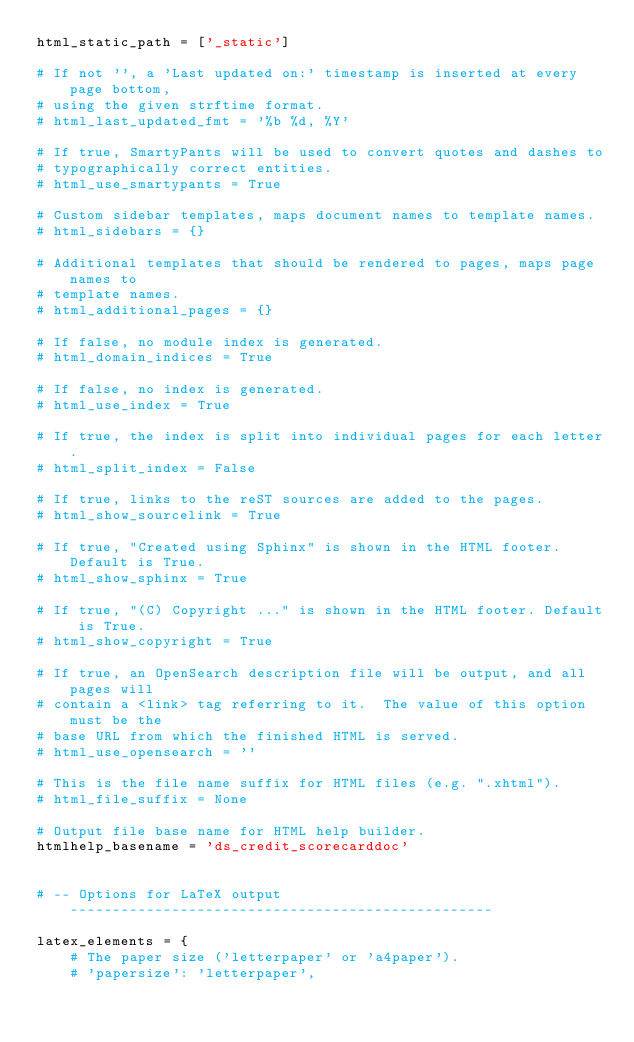Convert code to text. <code><loc_0><loc_0><loc_500><loc_500><_Python_>html_static_path = ['_static']

# If not '', a 'Last updated on:' timestamp is inserted at every page bottom,
# using the given strftime format.
# html_last_updated_fmt = '%b %d, %Y'

# If true, SmartyPants will be used to convert quotes and dashes to
# typographically correct entities.
# html_use_smartypants = True

# Custom sidebar templates, maps document names to template names.
# html_sidebars = {}

# Additional templates that should be rendered to pages, maps page names to
# template names.
# html_additional_pages = {}

# If false, no module index is generated.
# html_domain_indices = True

# If false, no index is generated.
# html_use_index = True

# If true, the index is split into individual pages for each letter.
# html_split_index = False

# If true, links to the reST sources are added to the pages.
# html_show_sourcelink = True

# If true, "Created using Sphinx" is shown in the HTML footer. Default is True.
# html_show_sphinx = True

# If true, "(C) Copyright ..." is shown in the HTML footer. Default is True.
# html_show_copyright = True

# If true, an OpenSearch description file will be output, and all pages will
# contain a <link> tag referring to it.  The value of this option must be the
# base URL from which the finished HTML is served.
# html_use_opensearch = ''

# This is the file name suffix for HTML files (e.g. ".xhtml").
# html_file_suffix = None

# Output file base name for HTML help builder.
htmlhelp_basename = 'ds_credit_scorecarddoc'


# -- Options for LaTeX output --------------------------------------------------

latex_elements = {
    # The paper size ('letterpaper' or 'a4paper').
    # 'papersize': 'letterpaper',
</code> 